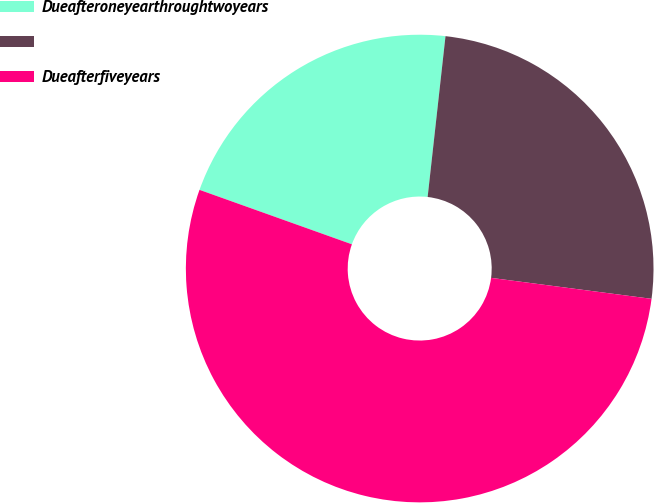Convert chart. <chart><loc_0><loc_0><loc_500><loc_500><pie_chart><fcel>Dueafteroneyearthroughtwoyears<fcel>Unnamed: 1<fcel>Dueafterfiveyears<nl><fcel>21.3%<fcel>25.31%<fcel>53.4%<nl></chart> 